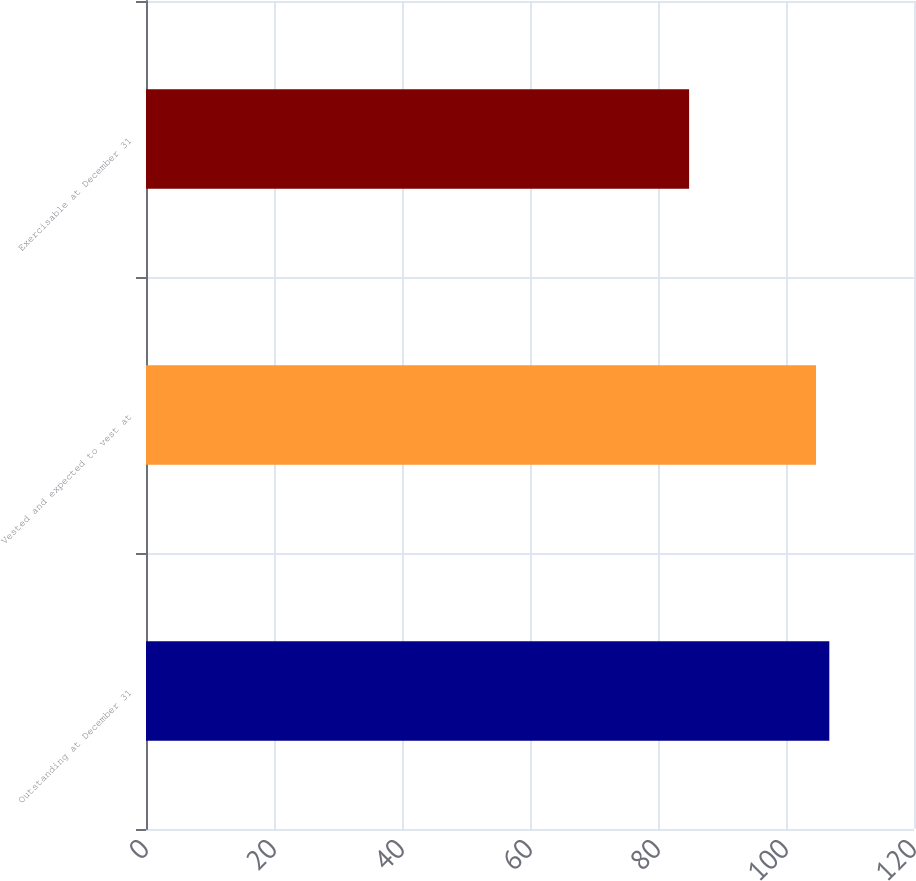<chart> <loc_0><loc_0><loc_500><loc_500><bar_chart><fcel>Outstanding at December 31<fcel>Vested and expected to vest at<fcel>Exercisable at December 31<nl><fcel>106.77<fcel>104.69<fcel>84.86<nl></chart> 